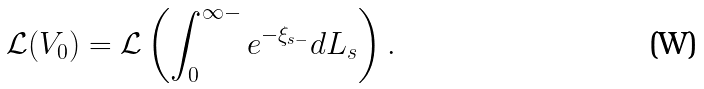Convert formula to latex. <formula><loc_0><loc_0><loc_500><loc_500>\mathcal { L } ( V _ { 0 } ) = \mathcal { L } \left ( \int _ { 0 } ^ { \infty - } e ^ { - \xi _ { s - } } d L _ { s } \right ) .</formula> 